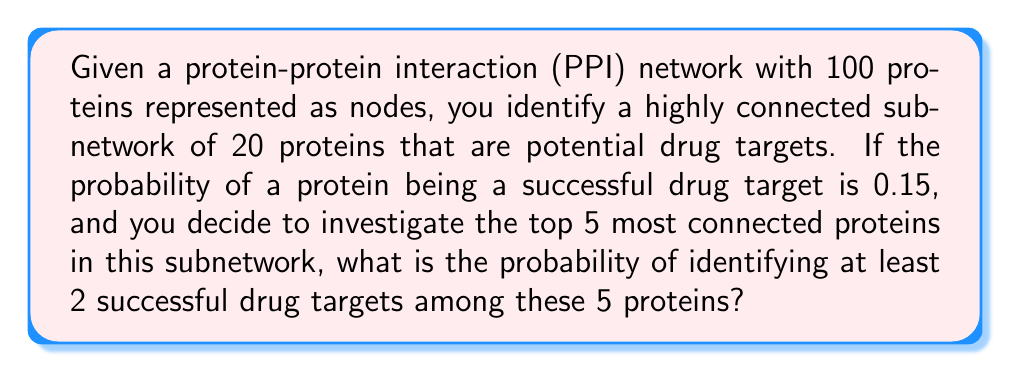Give your solution to this math problem. To solve this problem, we'll use concepts from graph theory and probability theory. Let's break it down step-by-step:

1) We're dealing with a binomial probability problem. We want to find the probability of at least 2 successes in 5 trials, where each trial has a probability of 0.15 of being successful.

2) The probability of at least 2 successes is equal to 1 minus the probability of 0 or 1 success.

3) Let's define:
   $p = 0.15$ (probability of success)
   $q = 1 - p = 0.85$ (probability of failure)
   $n = 5$ (number of trials)

4) The probability of exactly $k$ successes in $n$ trials is given by the binomial probability formula:

   $P(X = k) = \binom{n}{k} p^k q^{n-k}$

5) We need to calculate:

   $P(X \geq 2) = 1 - [P(X = 0) + P(X = 1)]$

6) Let's calculate each part:

   $P(X = 0) = \binom{5}{0} 0.15^0 0.85^5 = 1 \cdot 1 \cdot 0.44370 = 0.44370$

   $P(X = 1) = \binom{5}{1} 0.15^1 0.85^4 = 5 \cdot 0.15 \cdot 0.52200 = 0.39150$

7) Now we can calculate the final probability:

   $P(X \geq 2) = 1 - [P(X = 0) + P(X = 1)]$
                $= 1 - [0.44370 + 0.39150]$
                $= 1 - 0.83520$
                $= 0.16480$

Thus, the probability of identifying at least 2 successful drug targets among the 5 most connected proteins is approximately 0.16480 or 16.48%.
Answer: 0.16480 (or 16.48%) 